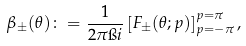Convert formula to latex. <formula><loc_0><loc_0><loc_500><loc_500>\beta _ { \pm } ( \theta ) \colon = \frac { 1 } { 2 \pi \i i } \left [ F _ { \pm } ( \theta ; p ) \right ] _ { p = - \pi } ^ { p = \pi } ,</formula> 